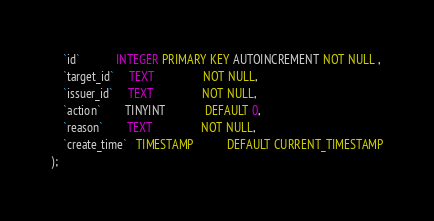Convert code to text. <code><loc_0><loc_0><loc_500><loc_500><_SQL_>    `id`            INTEGER PRIMARY KEY AUTOINCREMENT NOT NULL ,
    `target_id`     TEXT                NOT NULL,
    `issuer_id`     TEXT                NOT NULL,
    `action`        TINYINT             DEFAULT 0,
    `reason`        TEXT                NOT NULL,
    `create_time`   TIMESTAMP           DEFAULT CURRENT_TIMESTAMP
);</code> 